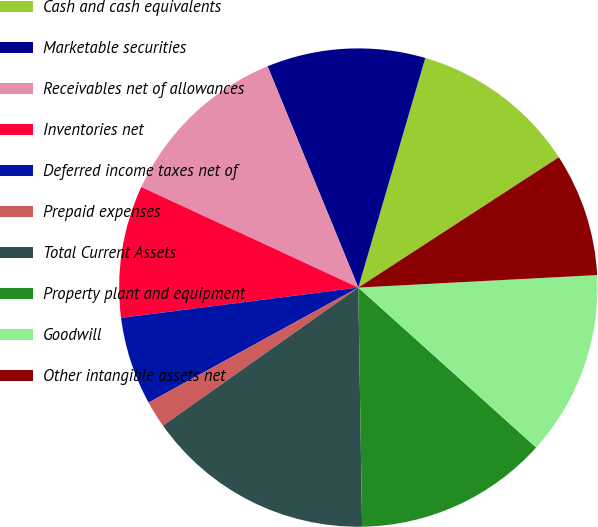<chart> <loc_0><loc_0><loc_500><loc_500><pie_chart><fcel>Cash and cash equivalents<fcel>Marketable securities<fcel>Receivables net of allowances<fcel>Inventories net<fcel>Deferred income taxes net of<fcel>Prepaid expenses<fcel>Total Current Assets<fcel>Property plant and equipment<fcel>Goodwill<fcel>Other intangible assets net<nl><fcel>11.31%<fcel>10.71%<fcel>11.9%<fcel>8.93%<fcel>5.96%<fcel>1.81%<fcel>15.46%<fcel>13.09%<fcel>12.49%<fcel>8.34%<nl></chart> 